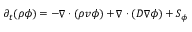<formula> <loc_0><loc_0><loc_500><loc_500>\begin{array} { r } { \partial _ { t } ( \rho \phi ) = - \nabla \cdot ( \rho v \phi ) + \nabla \cdot ( D \nabla \phi ) + S _ { \phi } } \end{array}</formula> 